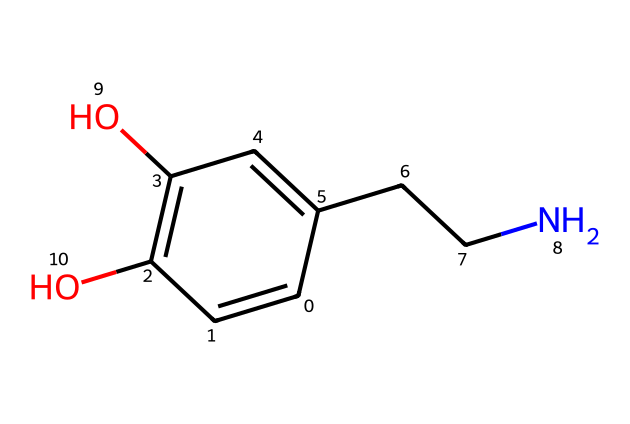how many carbon atoms are present in this molecule? By analyzing the SMILES representation, we can count the number of carbon atoms. The representation shows 10 carbon atoms total.
Answer: 10 what functional groups are present in this structure? In the SMILES representation, we can identify hydroxyl (-OH) groups indicated by the 'O', showing that there are two hydroxyl functional groups present.
Answer: two hydroxyl groups which atom in the chemical structure is responsible for its role as a neurotransmitter? The nitrogen atom (N) in the structure contributes to the formation of amines, which are commonly associated with neurotransmitters like dopamine. Here, the nitrogen is part of a side chain contributing to its function.
Answer: nitrogen how many double bonds are in this structure? The chemical structure contains two double bonds, which can be identified from the connections between carbon atoms denoted by '=' in the SMILES.
Answer: 2 what is the primary characteristic of dopamine related to its structure? Dopamine, as indicated by its structure, is characterized by the presence of a phenolic hydroxyl group, which contributes to its hydrophilic properties and biological activity.
Answer: phenolic hydroxyl group what type of molecule is this compound classified as? This compound is classified as a biogenic amine because of the presence of an amino group (NH) and its function as a neurotransmitter.
Answer: biogenic amine how does the presence of hydroxyl groups affect the solubility of this molecule? The hydroxyl groups increase the polarity of the molecule, enhancing its ability to interact with water and thus increasing its solubility in aqueous environments.
Answer: increases solubility 